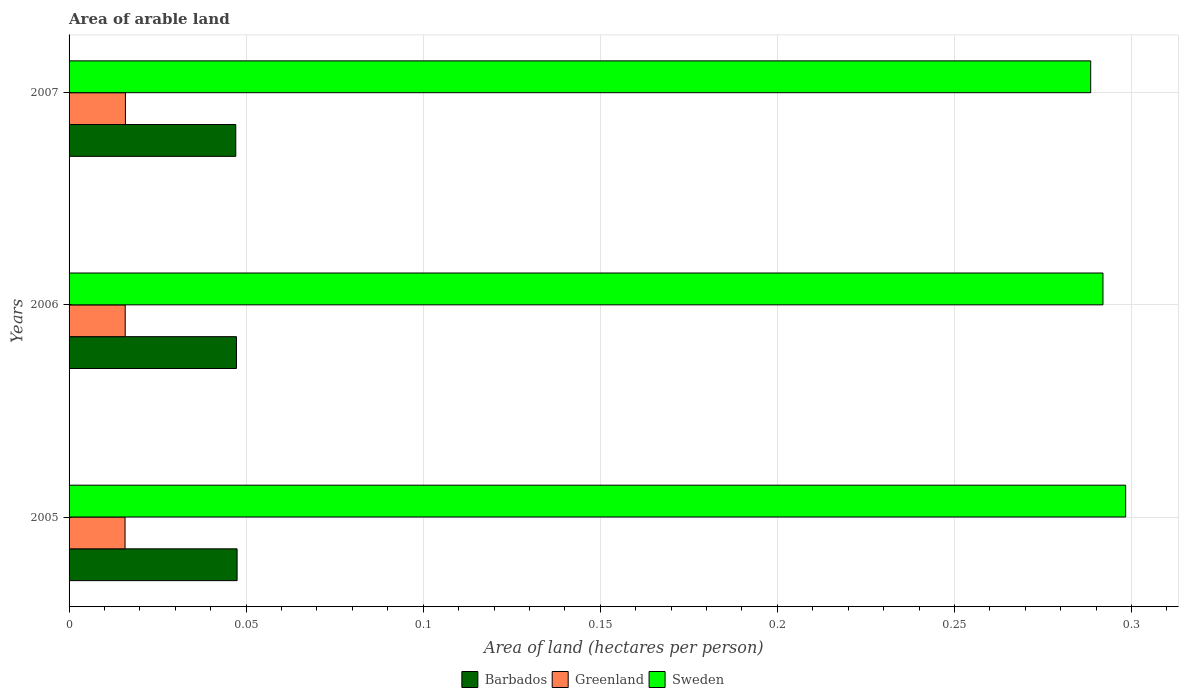How many bars are there on the 3rd tick from the top?
Your response must be concise. 3. What is the total arable land in Greenland in 2006?
Offer a very short reply. 0.02. Across all years, what is the maximum total arable land in Greenland?
Give a very brief answer. 0.02. Across all years, what is the minimum total arable land in Barbados?
Offer a very short reply. 0.05. In which year was the total arable land in Greenland minimum?
Keep it short and to the point. 2005. What is the total total arable land in Greenland in the graph?
Make the answer very short. 0.05. What is the difference between the total arable land in Greenland in 2005 and that in 2007?
Your answer should be very brief. -0. What is the difference between the total arable land in Greenland in 2006 and the total arable land in Sweden in 2007?
Your response must be concise. -0.27. What is the average total arable land in Sweden per year?
Give a very brief answer. 0.29. In the year 2005, what is the difference between the total arable land in Sweden and total arable land in Greenland?
Make the answer very short. 0.28. What is the ratio of the total arable land in Sweden in 2005 to that in 2007?
Provide a short and direct response. 1.03. Is the total arable land in Greenland in 2005 less than that in 2007?
Offer a terse response. Yes. Is the difference between the total arable land in Sweden in 2005 and 2007 greater than the difference between the total arable land in Greenland in 2005 and 2007?
Offer a terse response. Yes. What is the difference between the highest and the second highest total arable land in Barbados?
Offer a very short reply. 0. What is the difference between the highest and the lowest total arable land in Barbados?
Provide a short and direct response. 0. In how many years, is the total arable land in Sweden greater than the average total arable land in Sweden taken over all years?
Give a very brief answer. 1. What does the 3rd bar from the top in 2006 represents?
Offer a very short reply. Barbados. How many years are there in the graph?
Your answer should be very brief. 3. Are the values on the major ticks of X-axis written in scientific E-notation?
Provide a short and direct response. No. Does the graph contain grids?
Offer a terse response. Yes. Where does the legend appear in the graph?
Make the answer very short. Bottom center. How are the legend labels stacked?
Your response must be concise. Horizontal. What is the title of the graph?
Provide a succinct answer. Area of arable land. What is the label or title of the X-axis?
Your response must be concise. Area of land (hectares per person). What is the label or title of the Y-axis?
Keep it short and to the point. Years. What is the Area of land (hectares per person) of Barbados in 2005?
Provide a succinct answer. 0.05. What is the Area of land (hectares per person) of Greenland in 2005?
Your response must be concise. 0.02. What is the Area of land (hectares per person) of Sweden in 2005?
Provide a short and direct response. 0.3. What is the Area of land (hectares per person) in Barbados in 2006?
Provide a short and direct response. 0.05. What is the Area of land (hectares per person) of Greenland in 2006?
Keep it short and to the point. 0.02. What is the Area of land (hectares per person) of Sweden in 2006?
Ensure brevity in your answer.  0.29. What is the Area of land (hectares per person) in Barbados in 2007?
Give a very brief answer. 0.05. What is the Area of land (hectares per person) of Greenland in 2007?
Give a very brief answer. 0.02. What is the Area of land (hectares per person) in Sweden in 2007?
Your answer should be compact. 0.29. Across all years, what is the maximum Area of land (hectares per person) of Barbados?
Provide a short and direct response. 0.05. Across all years, what is the maximum Area of land (hectares per person) in Greenland?
Keep it short and to the point. 0.02. Across all years, what is the maximum Area of land (hectares per person) in Sweden?
Your answer should be compact. 0.3. Across all years, what is the minimum Area of land (hectares per person) of Barbados?
Provide a short and direct response. 0.05. Across all years, what is the minimum Area of land (hectares per person) of Greenland?
Make the answer very short. 0.02. Across all years, what is the minimum Area of land (hectares per person) of Sweden?
Give a very brief answer. 0.29. What is the total Area of land (hectares per person) in Barbados in the graph?
Ensure brevity in your answer.  0.14. What is the total Area of land (hectares per person) of Greenland in the graph?
Make the answer very short. 0.05. What is the total Area of land (hectares per person) of Sweden in the graph?
Make the answer very short. 0.88. What is the difference between the Area of land (hectares per person) of Barbados in 2005 and that in 2006?
Offer a very short reply. 0. What is the difference between the Area of land (hectares per person) of Sweden in 2005 and that in 2006?
Provide a short and direct response. 0.01. What is the difference between the Area of land (hectares per person) in Greenland in 2005 and that in 2007?
Provide a short and direct response. -0. What is the difference between the Area of land (hectares per person) in Sweden in 2005 and that in 2007?
Make the answer very short. 0.01. What is the difference between the Area of land (hectares per person) of Barbados in 2006 and that in 2007?
Provide a succinct answer. 0. What is the difference between the Area of land (hectares per person) in Greenland in 2006 and that in 2007?
Your answer should be compact. -0. What is the difference between the Area of land (hectares per person) in Sweden in 2006 and that in 2007?
Your response must be concise. 0. What is the difference between the Area of land (hectares per person) of Barbados in 2005 and the Area of land (hectares per person) of Greenland in 2006?
Make the answer very short. 0.03. What is the difference between the Area of land (hectares per person) of Barbados in 2005 and the Area of land (hectares per person) of Sweden in 2006?
Make the answer very short. -0.24. What is the difference between the Area of land (hectares per person) of Greenland in 2005 and the Area of land (hectares per person) of Sweden in 2006?
Your answer should be very brief. -0.28. What is the difference between the Area of land (hectares per person) of Barbados in 2005 and the Area of land (hectares per person) of Greenland in 2007?
Provide a succinct answer. 0.03. What is the difference between the Area of land (hectares per person) of Barbados in 2005 and the Area of land (hectares per person) of Sweden in 2007?
Your answer should be very brief. -0.24. What is the difference between the Area of land (hectares per person) in Greenland in 2005 and the Area of land (hectares per person) in Sweden in 2007?
Your answer should be compact. -0.27. What is the difference between the Area of land (hectares per person) in Barbados in 2006 and the Area of land (hectares per person) in Greenland in 2007?
Provide a short and direct response. 0.03. What is the difference between the Area of land (hectares per person) in Barbados in 2006 and the Area of land (hectares per person) in Sweden in 2007?
Your response must be concise. -0.24. What is the difference between the Area of land (hectares per person) of Greenland in 2006 and the Area of land (hectares per person) of Sweden in 2007?
Your answer should be compact. -0.27. What is the average Area of land (hectares per person) of Barbados per year?
Keep it short and to the point. 0.05. What is the average Area of land (hectares per person) of Greenland per year?
Offer a terse response. 0.02. What is the average Area of land (hectares per person) in Sweden per year?
Offer a very short reply. 0.29. In the year 2005, what is the difference between the Area of land (hectares per person) in Barbados and Area of land (hectares per person) in Greenland?
Offer a very short reply. 0.03. In the year 2005, what is the difference between the Area of land (hectares per person) in Barbados and Area of land (hectares per person) in Sweden?
Offer a terse response. -0.25. In the year 2005, what is the difference between the Area of land (hectares per person) of Greenland and Area of land (hectares per person) of Sweden?
Provide a succinct answer. -0.28. In the year 2006, what is the difference between the Area of land (hectares per person) in Barbados and Area of land (hectares per person) in Greenland?
Offer a very short reply. 0.03. In the year 2006, what is the difference between the Area of land (hectares per person) in Barbados and Area of land (hectares per person) in Sweden?
Make the answer very short. -0.24. In the year 2006, what is the difference between the Area of land (hectares per person) in Greenland and Area of land (hectares per person) in Sweden?
Provide a short and direct response. -0.28. In the year 2007, what is the difference between the Area of land (hectares per person) of Barbados and Area of land (hectares per person) of Greenland?
Keep it short and to the point. 0.03. In the year 2007, what is the difference between the Area of land (hectares per person) of Barbados and Area of land (hectares per person) of Sweden?
Your answer should be very brief. -0.24. In the year 2007, what is the difference between the Area of land (hectares per person) of Greenland and Area of land (hectares per person) of Sweden?
Provide a short and direct response. -0.27. What is the ratio of the Area of land (hectares per person) of Greenland in 2005 to that in 2006?
Ensure brevity in your answer.  1. What is the ratio of the Area of land (hectares per person) of Sweden in 2005 to that in 2006?
Provide a short and direct response. 1.02. What is the ratio of the Area of land (hectares per person) in Sweden in 2005 to that in 2007?
Provide a succinct answer. 1.03. What is the ratio of the Area of land (hectares per person) in Greenland in 2006 to that in 2007?
Offer a very short reply. 1. What is the ratio of the Area of land (hectares per person) of Sweden in 2006 to that in 2007?
Make the answer very short. 1.01. What is the difference between the highest and the second highest Area of land (hectares per person) in Greenland?
Your answer should be very brief. 0. What is the difference between the highest and the second highest Area of land (hectares per person) of Sweden?
Your answer should be compact. 0.01. What is the difference between the highest and the lowest Area of land (hectares per person) in Greenland?
Your answer should be compact. 0. What is the difference between the highest and the lowest Area of land (hectares per person) of Sweden?
Your response must be concise. 0.01. 